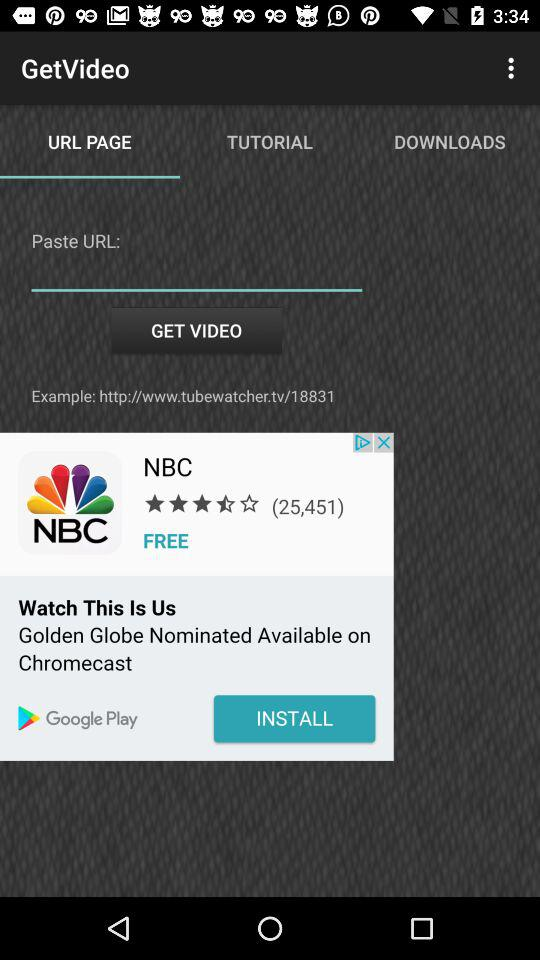Which option is selected in "GetVideo"? The selected option is "URL PAGE". 